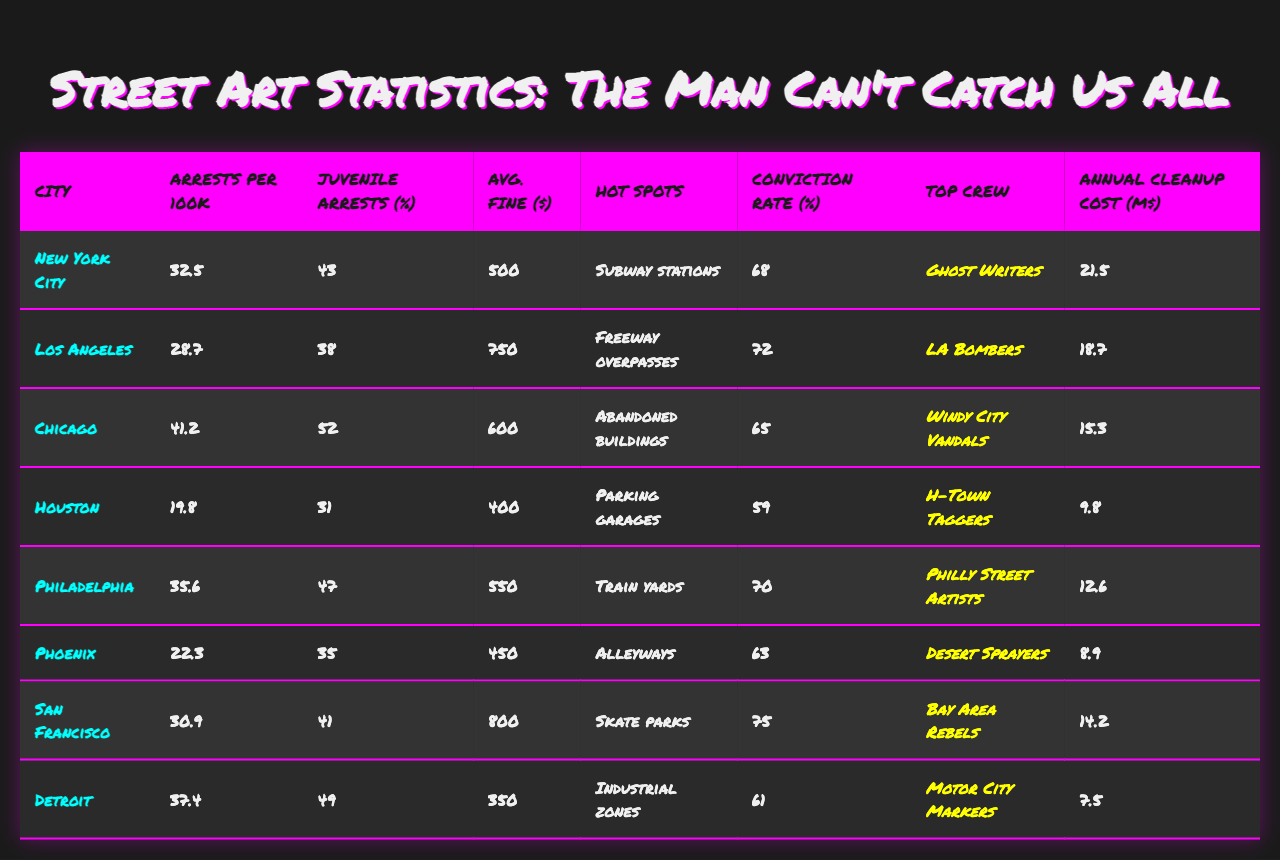What city has the highest arrest rate per 100k population? By scanning through the arrest rates listed for each city, New York City has the highest rate at 32.5 per 100k population.
Answer: New York City Which city has the lowest estimated annual cleanup cost? The estimated annual cleanup costs are compared, and the lowest figure is for Detroit at 7.5 million dollars.
Answer: Detroit What percentage of arrests in Chicago lead to conviction? Looking at the specified column for Chicago, 65% of arrests lead to a conviction.
Answer: 65% Which crew is identified as the most active in San Francisco? By checking the corresponding row for San Francisco, the top crew listed is the Bay Area Rebels.
Answer: Bay Area Rebels In which city are juvenile arrests the highest percentage of total arrests? Reviewing the percentage of juvenile arrests, Chicago has the highest juvenile arrest percentage at 52%.
Answer: Chicago What is the average fine amount across all listed cities? To find the average, sum all the average fine amounts: (500 + 750 + 600 + 400 + 550 + 450 + 800 + 350) = 4350, then divide by 8 cities to get 543.75.
Answer: 543.75 Which city has a higher conviction rate, Los Angeles or Houston? Los Angeles has a conviction rate of 72%, while Houston has a rate of 59%, so Los Angeles has a higher conviction rate.
Answer: Los Angeles What is the difference in arrests per 100k population between Philadelphia and Phoenix? The arrests per 100k for Philadelphia is 35.6 and for Phoenix is 22.3. The difference is 35.6 - 22.3 = 13.3.
Answer: 13.3 Are the most active crews from Houston and Detroit the same? Checking the most active crew of Houston, it's H-Town Taggers, and for Detroit, it's Motor City Markers; they are different crews.
Answer: No Which city has both the highest average fine amount and the highest percentage of juvenile arrests? By examining the data, San Francisco has the highest average fine amount at 800 dollars and a juvenile arrest percentage of 41%, making it not eligible for the highest juvenile arrest percentage, which is Chicago with 52%. Therefore, no city meets both criteria.
Answer: None 